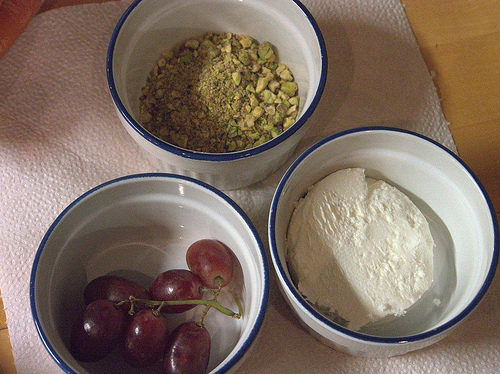<image>
Is there a flour to the left of the grapes? No. The flour is not to the left of the grapes. From this viewpoint, they have a different horizontal relationship. Is there a grapes next to the bowl? No. The grapes is not positioned next to the bowl. They are located in different areas of the scene. 